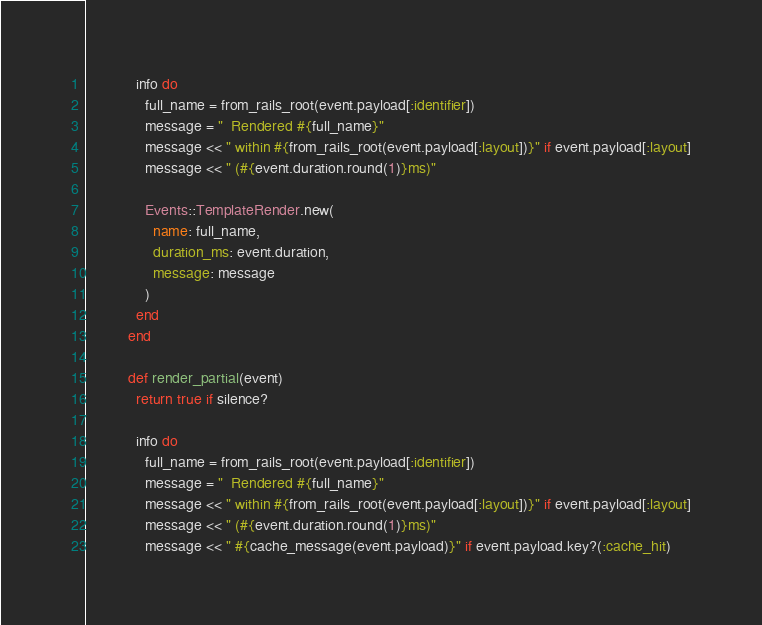Convert code to text. <code><loc_0><loc_0><loc_500><loc_500><_Ruby_>            info do
              full_name = from_rails_root(event.payload[:identifier])
              message = "  Rendered #{full_name}"
              message << " within #{from_rails_root(event.payload[:layout])}" if event.payload[:layout]
              message << " (#{event.duration.round(1)}ms)"

              Events::TemplateRender.new(
                name: full_name,
                duration_ms: event.duration,
                message: message
              )
            end
          end

          def render_partial(event)
            return true if silence?

            info do
              full_name = from_rails_root(event.payload[:identifier])
              message = "  Rendered #{full_name}"
              message << " within #{from_rails_root(event.payload[:layout])}" if event.payload[:layout]
              message << " (#{event.duration.round(1)}ms)"
              message << " #{cache_message(event.payload)}" if event.payload.key?(:cache_hit)
</code> 